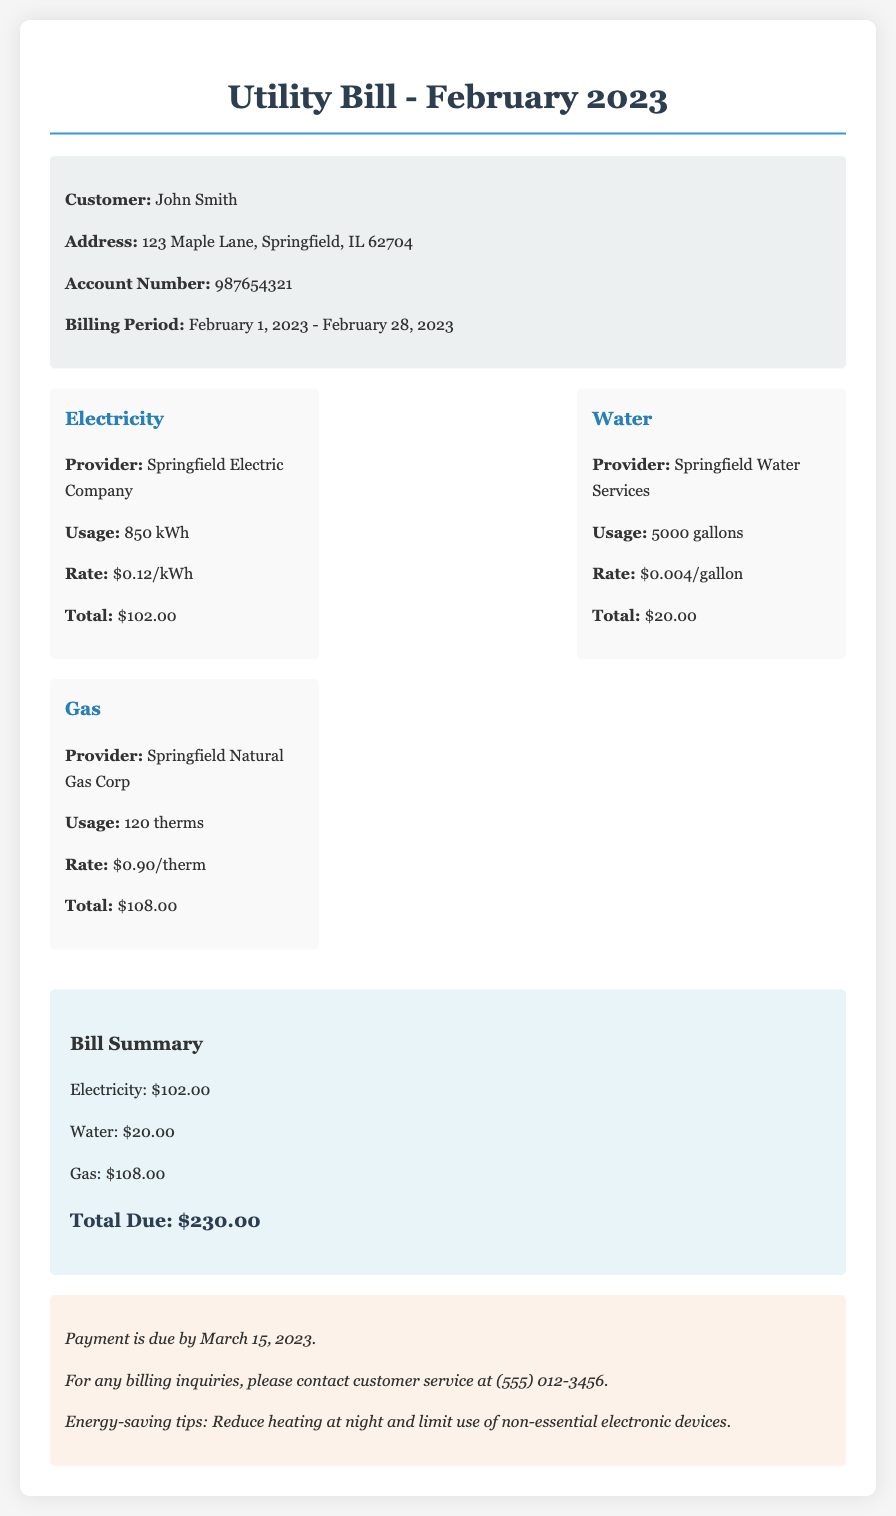what is the total amount due? The total amount due is presented in the summary section of the bill, which shows the cumulative costs for electricity, water, and gas.
Answer: $230.00 who is the electricity provider? The electricity provider is mentioned under the electricity section, specifying the company responsible for supplying electricity.
Answer: Springfield Electric Company how many gallons of water were used? The usage for water consumption is explicitly stated in the water section of the bill.
Answer: 5000 gallons what is the rate for gas usage? The rate for gas usage is provided in the gas section, detailing the cost per therm for gas consumption.
Answer: $0.90/therm when is the payment due? The due date for payment is found in the notes section, indicating when the customer needs to pay the bill.
Answer: March 15, 2023 what is the gas usage in therms? The gas usage is listed in the gas section of the bill, directly stating the amount of therms consumed.
Answer: 120 therms what is the electricity usage in kWh? The usage for electricity consumption is clearly specified in the electricity section of the bill.
Answer: 850 kWh what amount is charged for water? The total amount billed for water usage is shown in the summary of the bill, summing up the water costs.
Answer: $20.00 what style of font is used in the document? The document specifies a particular font style used for the text within the content.
Answer: Georgia 